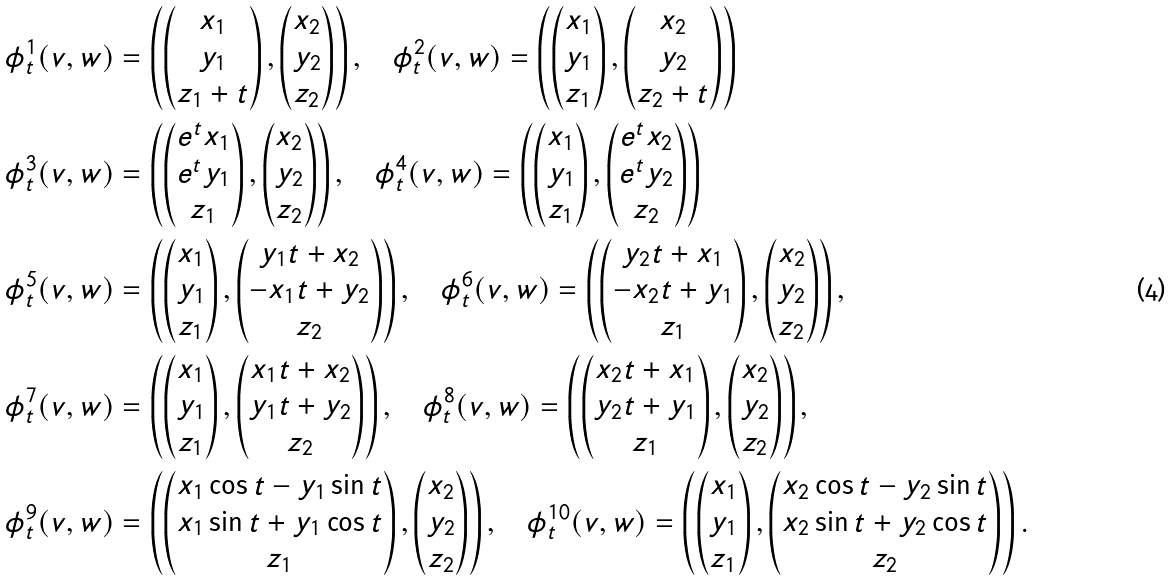<formula> <loc_0><loc_0><loc_500><loc_500>\phi ^ { 1 } _ { t } ( v , w ) & = \left ( \begin{pmatrix} x _ { 1 } \\ y _ { 1 } \\ z _ { 1 } + t \end{pmatrix} , \begin{pmatrix} x _ { 2 } \\ y _ { 2 } \\ z _ { 2 } \end{pmatrix} \right ) , \quad \phi ^ { 2 } _ { t } ( v , w ) = \left ( \begin{pmatrix} x _ { 1 } \\ y _ { 1 } \\ z _ { 1 } \end{pmatrix} , \begin{pmatrix} x _ { 2 } \\ y _ { 2 } \\ z _ { 2 } + t \end{pmatrix} \right ) \\ \phi ^ { 3 } _ { t } ( v , w ) & = \left ( \begin{pmatrix} e ^ { t } x _ { 1 } \\ e ^ { t } y _ { 1 } \\ z _ { 1 } \end{pmatrix} , \begin{pmatrix} x _ { 2 } \\ y _ { 2 } \\ z _ { 2 } \end{pmatrix} \right ) , \quad \phi ^ { 4 } _ { t } ( v , w ) = \left ( \begin{pmatrix} x _ { 1 } \\ y _ { 1 } \\ z _ { 1 } \end{pmatrix} , \begin{pmatrix} e ^ { t } x _ { 2 } \\ e ^ { t } y _ { 2 } \\ z _ { 2 } \end{pmatrix} \right ) \\ \phi ^ { 5 } _ { t } ( v , w ) & = \left ( \begin{pmatrix} x _ { 1 } \\ y _ { 1 } \\ z _ { 1 } \end{pmatrix} , \begin{pmatrix} y _ { 1 } t + x _ { 2 } \\ - x _ { 1 } t + y _ { 2 } \\ z _ { 2 } \end{pmatrix} \right ) , \quad \phi ^ { 6 } _ { t } ( v , w ) = \left ( \begin{pmatrix} y _ { 2 } t + x _ { 1 } \\ - x _ { 2 } t + y _ { 1 } \\ z _ { 1 } \end{pmatrix} , \begin{pmatrix} x _ { 2 } \\ y _ { 2 } \\ z _ { 2 } \end{pmatrix} \right ) , \\ \phi ^ { 7 } _ { t } ( v , w ) & = \left ( \begin{pmatrix} x _ { 1 } \\ y _ { 1 } \\ z _ { 1 } \end{pmatrix} , \begin{pmatrix} x _ { 1 } t + x _ { 2 } \\ y _ { 1 } t + y _ { 2 } \\ z _ { 2 } \end{pmatrix} \right ) , \quad \phi ^ { 8 } _ { t } ( v , w ) = \left ( \begin{pmatrix} x _ { 2 } t + x _ { 1 } \\ y _ { 2 } t + y _ { 1 } \\ z _ { 1 } \end{pmatrix} , \begin{pmatrix} x _ { 2 } \\ y _ { 2 } \\ z _ { 2 } \end{pmatrix} \right ) , \\ \phi ^ { 9 } _ { t } ( v , w ) & = \left ( \begin{pmatrix} x _ { 1 } \cos t - y _ { 1 } \sin t \\ x _ { 1 } \sin t + y _ { 1 } \cos t \\ z _ { 1 } \end{pmatrix} , \begin{pmatrix} x _ { 2 } \\ y _ { 2 } \\ z _ { 2 } \end{pmatrix} \right ) , \quad \phi ^ { 1 0 } _ { t } ( v , w ) = \left ( \begin{pmatrix} x _ { 1 } \\ y _ { 1 } \\ z _ { 1 } \end{pmatrix} , \begin{pmatrix} x _ { 2 } \cos t - y _ { 2 } \sin t \\ x _ { 2 } \sin t + y _ { 2 } \cos t \\ z _ { 2 } \end{pmatrix} \right ) .</formula> 